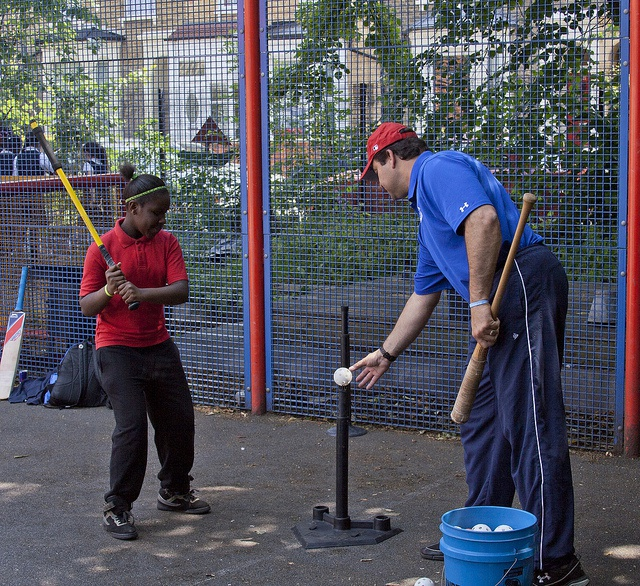Describe the objects in this image and their specific colors. I can see people in darkgreen, black, navy, blue, and gray tones, people in darkgreen, black, maroon, gray, and brown tones, backpack in darkgreen, black, gray, and darkblue tones, baseball bat in darkgreen, black, gray, and maroon tones, and people in darkgreen, black, gray, and maroon tones in this image. 